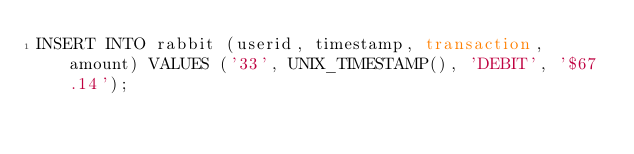<code> <loc_0><loc_0><loc_500><loc_500><_SQL_>INSERT INTO rabbit (userid, timestamp, transaction, amount) VALUES ('33', UNIX_TIMESTAMP(), 'DEBIT', '$67.14');
</code> 